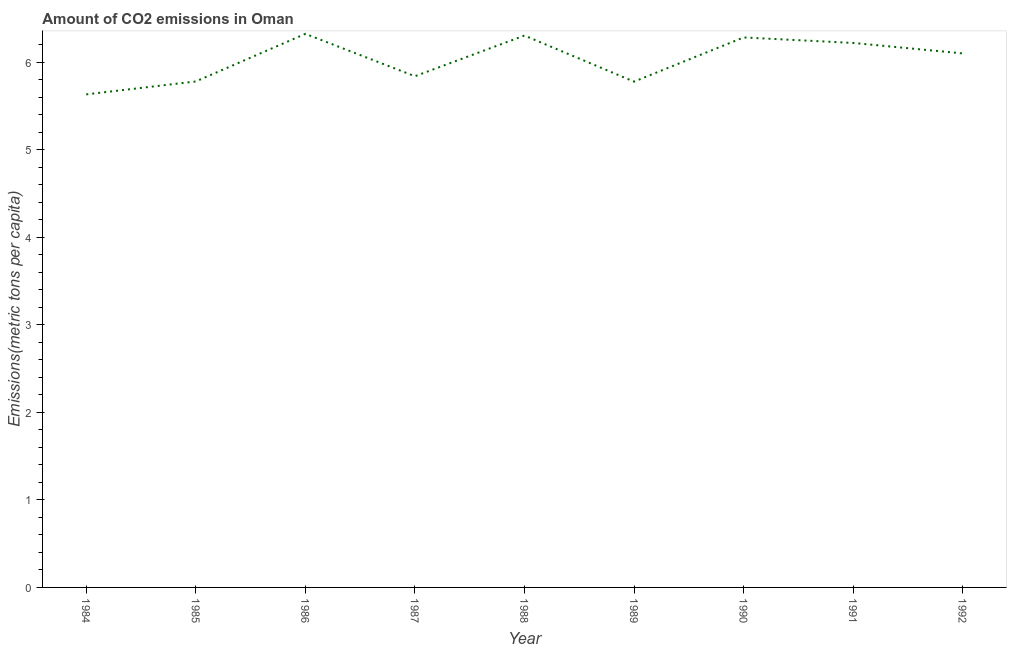What is the amount of co2 emissions in 1988?
Offer a very short reply. 6.3. Across all years, what is the maximum amount of co2 emissions?
Your answer should be very brief. 6.32. Across all years, what is the minimum amount of co2 emissions?
Provide a short and direct response. 5.63. What is the sum of the amount of co2 emissions?
Offer a terse response. 54.27. What is the difference between the amount of co2 emissions in 1989 and 1991?
Give a very brief answer. -0.44. What is the average amount of co2 emissions per year?
Give a very brief answer. 6.03. What is the median amount of co2 emissions?
Offer a terse response. 6.1. In how many years, is the amount of co2 emissions greater than 3.6 metric tons per capita?
Your answer should be compact. 9. What is the ratio of the amount of co2 emissions in 1985 to that in 1990?
Provide a short and direct response. 0.92. Is the difference between the amount of co2 emissions in 1988 and 1989 greater than the difference between any two years?
Keep it short and to the point. No. What is the difference between the highest and the second highest amount of co2 emissions?
Make the answer very short. 0.02. Is the sum of the amount of co2 emissions in 1986 and 1992 greater than the maximum amount of co2 emissions across all years?
Your answer should be compact. Yes. What is the difference between the highest and the lowest amount of co2 emissions?
Your response must be concise. 0.69. How many years are there in the graph?
Keep it short and to the point. 9. What is the difference between two consecutive major ticks on the Y-axis?
Keep it short and to the point. 1. What is the title of the graph?
Provide a succinct answer. Amount of CO2 emissions in Oman. What is the label or title of the Y-axis?
Give a very brief answer. Emissions(metric tons per capita). What is the Emissions(metric tons per capita) in 1984?
Provide a succinct answer. 5.63. What is the Emissions(metric tons per capita) in 1985?
Make the answer very short. 5.78. What is the Emissions(metric tons per capita) in 1986?
Make the answer very short. 6.32. What is the Emissions(metric tons per capita) in 1987?
Your response must be concise. 5.84. What is the Emissions(metric tons per capita) in 1988?
Your answer should be very brief. 6.3. What is the Emissions(metric tons per capita) in 1989?
Give a very brief answer. 5.78. What is the Emissions(metric tons per capita) in 1990?
Ensure brevity in your answer.  6.28. What is the Emissions(metric tons per capita) of 1991?
Give a very brief answer. 6.22. What is the Emissions(metric tons per capita) of 1992?
Offer a very short reply. 6.1. What is the difference between the Emissions(metric tons per capita) in 1984 and 1985?
Provide a short and direct response. -0.15. What is the difference between the Emissions(metric tons per capita) in 1984 and 1986?
Offer a terse response. -0.69. What is the difference between the Emissions(metric tons per capita) in 1984 and 1987?
Give a very brief answer. -0.21. What is the difference between the Emissions(metric tons per capita) in 1984 and 1988?
Make the answer very short. -0.67. What is the difference between the Emissions(metric tons per capita) in 1984 and 1989?
Keep it short and to the point. -0.15. What is the difference between the Emissions(metric tons per capita) in 1984 and 1990?
Make the answer very short. -0.65. What is the difference between the Emissions(metric tons per capita) in 1984 and 1991?
Keep it short and to the point. -0.59. What is the difference between the Emissions(metric tons per capita) in 1984 and 1992?
Ensure brevity in your answer.  -0.47. What is the difference between the Emissions(metric tons per capita) in 1985 and 1986?
Provide a short and direct response. -0.54. What is the difference between the Emissions(metric tons per capita) in 1985 and 1987?
Ensure brevity in your answer.  -0.06. What is the difference between the Emissions(metric tons per capita) in 1985 and 1988?
Ensure brevity in your answer.  -0.52. What is the difference between the Emissions(metric tons per capita) in 1985 and 1989?
Ensure brevity in your answer.  0. What is the difference between the Emissions(metric tons per capita) in 1985 and 1990?
Offer a very short reply. -0.5. What is the difference between the Emissions(metric tons per capita) in 1985 and 1991?
Your answer should be compact. -0.44. What is the difference between the Emissions(metric tons per capita) in 1985 and 1992?
Your answer should be compact. -0.32. What is the difference between the Emissions(metric tons per capita) in 1986 and 1987?
Provide a succinct answer. 0.48. What is the difference between the Emissions(metric tons per capita) in 1986 and 1988?
Ensure brevity in your answer.  0.02. What is the difference between the Emissions(metric tons per capita) in 1986 and 1989?
Make the answer very short. 0.55. What is the difference between the Emissions(metric tons per capita) in 1986 and 1990?
Offer a terse response. 0.04. What is the difference between the Emissions(metric tons per capita) in 1986 and 1991?
Offer a terse response. 0.1. What is the difference between the Emissions(metric tons per capita) in 1986 and 1992?
Make the answer very short. 0.22. What is the difference between the Emissions(metric tons per capita) in 1987 and 1988?
Offer a very short reply. -0.46. What is the difference between the Emissions(metric tons per capita) in 1987 and 1989?
Make the answer very short. 0.06. What is the difference between the Emissions(metric tons per capita) in 1987 and 1990?
Offer a terse response. -0.44. What is the difference between the Emissions(metric tons per capita) in 1987 and 1991?
Your answer should be very brief. -0.38. What is the difference between the Emissions(metric tons per capita) in 1987 and 1992?
Provide a short and direct response. -0.26. What is the difference between the Emissions(metric tons per capita) in 1988 and 1989?
Give a very brief answer. 0.53. What is the difference between the Emissions(metric tons per capita) in 1988 and 1990?
Your response must be concise. 0.02. What is the difference between the Emissions(metric tons per capita) in 1988 and 1991?
Ensure brevity in your answer.  0.08. What is the difference between the Emissions(metric tons per capita) in 1988 and 1992?
Your response must be concise. 0.2. What is the difference between the Emissions(metric tons per capita) in 1989 and 1990?
Keep it short and to the point. -0.5. What is the difference between the Emissions(metric tons per capita) in 1989 and 1991?
Offer a terse response. -0.44. What is the difference between the Emissions(metric tons per capita) in 1989 and 1992?
Your answer should be very brief. -0.32. What is the difference between the Emissions(metric tons per capita) in 1990 and 1991?
Ensure brevity in your answer.  0.06. What is the difference between the Emissions(metric tons per capita) in 1990 and 1992?
Your answer should be compact. 0.18. What is the difference between the Emissions(metric tons per capita) in 1991 and 1992?
Your answer should be very brief. 0.12. What is the ratio of the Emissions(metric tons per capita) in 1984 to that in 1986?
Provide a succinct answer. 0.89. What is the ratio of the Emissions(metric tons per capita) in 1984 to that in 1988?
Your response must be concise. 0.89. What is the ratio of the Emissions(metric tons per capita) in 1984 to that in 1989?
Make the answer very short. 0.97. What is the ratio of the Emissions(metric tons per capita) in 1984 to that in 1990?
Your response must be concise. 0.9. What is the ratio of the Emissions(metric tons per capita) in 1984 to that in 1991?
Keep it short and to the point. 0.91. What is the ratio of the Emissions(metric tons per capita) in 1984 to that in 1992?
Give a very brief answer. 0.92. What is the ratio of the Emissions(metric tons per capita) in 1985 to that in 1986?
Give a very brief answer. 0.91. What is the ratio of the Emissions(metric tons per capita) in 1985 to that in 1988?
Provide a short and direct response. 0.92. What is the ratio of the Emissions(metric tons per capita) in 1985 to that in 1989?
Make the answer very short. 1. What is the ratio of the Emissions(metric tons per capita) in 1985 to that in 1991?
Your answer should be very brief. 0.93. What is the ratio of the Emissions(metric tons per capita) in 1985 to that in 1992?
Make the answer very short. 0.95. What is the ratio of the Emissions(metric tons per capita) in 1986 to that in 1987?
Provide a short and direct response. 1.08. What is the ratio of the Emissions(metric tons per capita) in 1986 to that in 1989?
Give a very brief answer. 1.09. What is the ratio of the Emissions(metric tons per capita) in 1986 to that in 1992?
Your answer should be compact. 1.04. What is the ratio of the Emissions(metric tons per capita) in 1987 to that in 1988?
Offer a terse response. 0.93. What is the ratio of the Emissions(metric tons per capita) in 1987 to that in 1990?
Ensure brevity in your answer.  0.93. What is the ratio of the Emissions(metric tons per capita) in 1987 to that in 1991?
Keep it short and to the point. 0.94. What is the ratio of the Emissions(metric tons per capita) in 1988 to that in 1989?
Your answer should be very brief. 1.09. What is the ratio of the Emissions(metric tons per capita) in 1988 to that in 1992?
Provide a succinct answer. 1.03. What is the ratio of the Emissions(metric tons per capita) in 1989 to that in 1991?
Your response must be concise. 0.93. What is the ratio of the Emissions(metric tons per capita) in 1989 to that in 1992?
Provide a short and direct response. 0.95. What is the ratio of the Emissions(metric tons per capita) in 1990 to that in 1991?
Provide a short and direct response. 1.01. What is the ratio of the Emissions(metric tons per capita) in 1991 to that in 1992?
Ensure brevity in your answer.  1.02. 